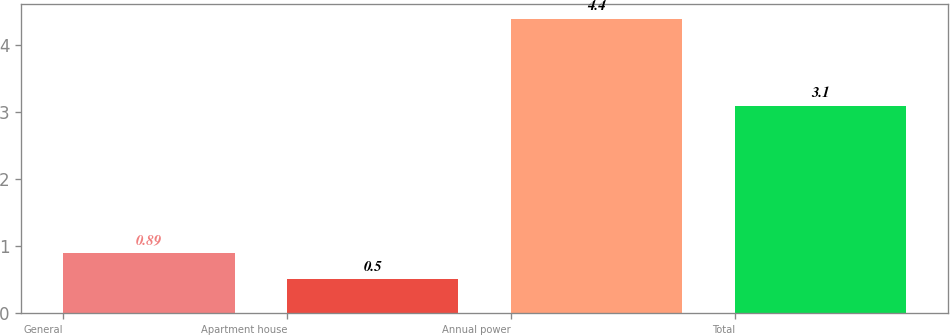Convert chart to OTSL. <chart><loc_0><loc_0><loc_500><loc_500><bar_chart><fcel>General<fcel>Apartment house<fcel>Annual power<fcel>Total<nl><fcel>0.89<fcel>0.5<fcel>4.4<fcel>3.1<nl></chart> 